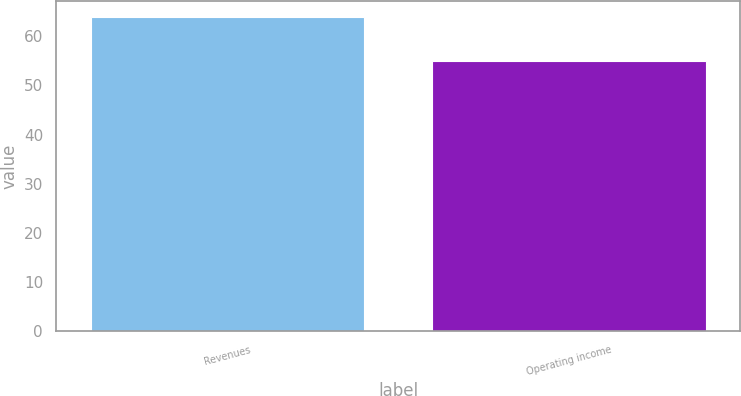Convert chart. <chart><loc_0><loc_0><loc_500><loc_500><bar_chart><fcel>Revenues<fcel>Operating income<nl><fcel>64<fcel>55<nl></chart> 